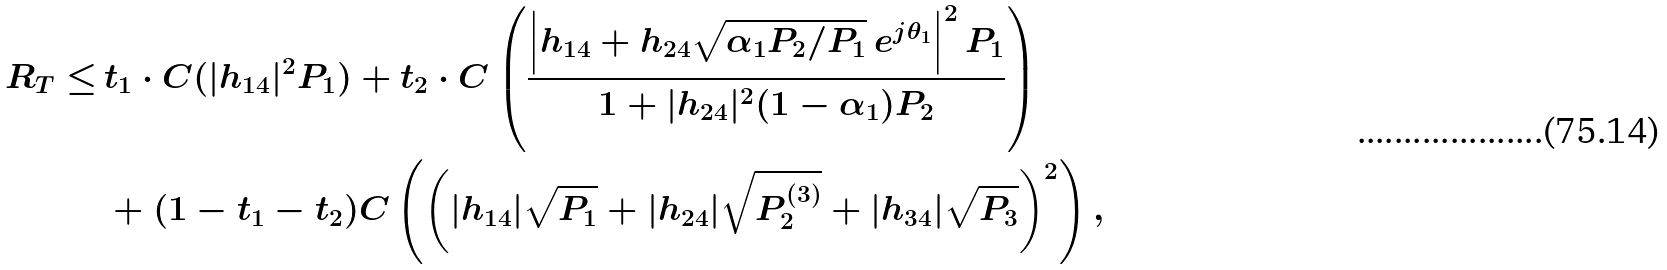Convert formula to latex. <formula><loc_0><loc_0><loc_500><loc_500>R _ { T } \leq \, & t _ { 1 } \cdot C ( | h _ { 1 4 } | ^ { 2 } P _ { 1 } ) + t _ { 2 } \cdot C \left ( \frac { \left | h _ { 1 4 } + h _ { 2 4 } \sqrt { \alpha _ { 1 } P _ { 2 } / P _ { 1 } } \ e ^ { j \theta _ { 1 } } \right | ^ { 2 } P _ { 1 } } { 1 + | h _ { 2 4 } | ^ { 2 } ( 1 - \alpha _ { 1 } ) P _ { 2 } } \right ) \\ & + ( 1 - t _ { 1 } - t _ { 2 } ) C \left ( \left ( | h _ { 1 4 } | \sqrt { P _ { 1 } } + | h _ { 2 4 } | \sqrt { P ^ { ( 3 ) } _ { 2 } } + | h _ { 3 4 } | \sqrt { P _ { 3 } } \right ) ^ { 2 } \right ) ,</formula> 